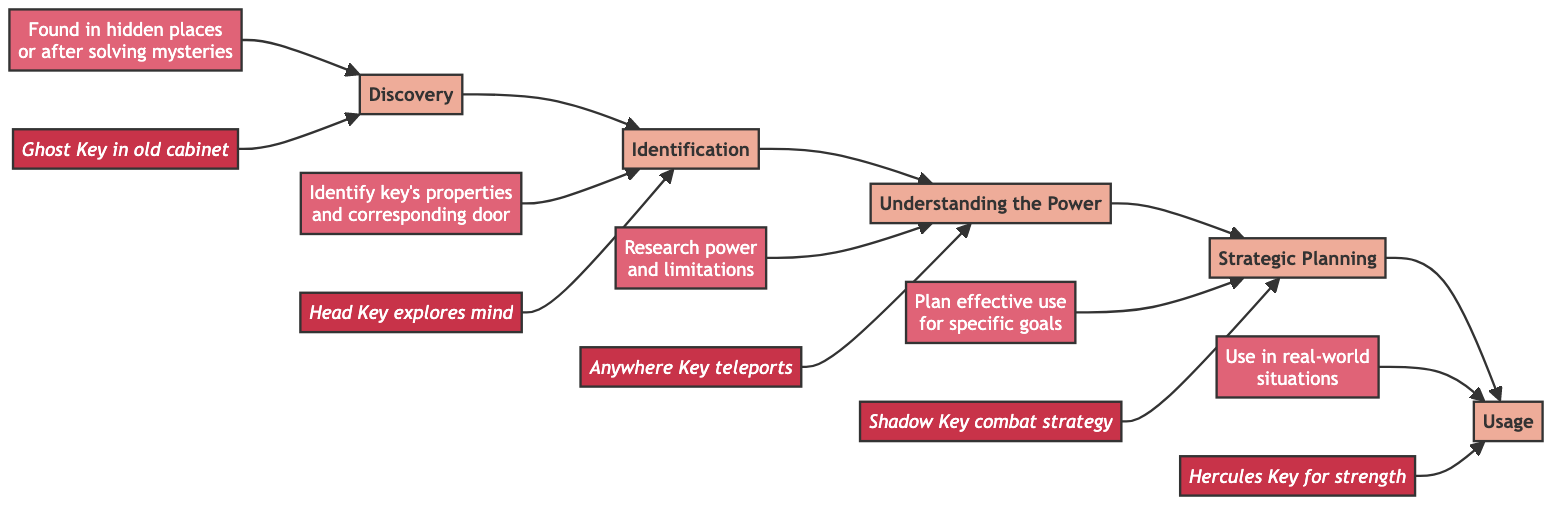What is the first stage in the journey of a key? The first stage is the beginning of the flowchart, labeled "Discovery" which is simply observable from the leftmost position in the diagram.
Answer: Discovery How many stages are there in the key's journey? Counting the stages listed sequentially in the flowchart, we can see there are five stages: Discovery, Identification, Understanding the Power, Strategic Planning, and Usage.
Answer: 5 What follows the "Identification" stage? By looking at the flowchart, we see that the node immediately after "Identification" is the "Understanding the Power" stage, indicating the sequences in which the stages occur.
Answer: Understanding the Power Which key is associated with the "Strategic Planning" stage? In the diagram, the key linked with Strategic Planning is the "Shadow Key," which is explicitly assigned as an example for this stage.
Answer: Shadow Key What is the relationship between "Understanding the Power" and "Usage"? The flowchart connects these two stages directly, with a directional arrow indicating that "Usage" follows "Understanding the Power," establishing a sequential relationship.
Answer: Sequential Identify an example provided in the "Discovery" stage. The diagram includes "Ghost Key in old cabinet" as a specific example associated with the Discovery stage, which can be clearly seen mentioned in the respective section.
Answer: Ghost Key in old cabinet Which stage involves researching the power and limitations of the key? The description associated with "Understanding the Power" specifies activities involving research regarding the key's abilities, placing it as the correct stage for this activity.
Answer: Understanding the Power What is the main objective during the "Strategic Planning" stage? Looking at the associated description for the Strategic Planning stage, the main objective is to "plan effective use for specific goals," highlighting its purpose in the process.
Answer: Plan effective use for specific goals What example is linked with the "Usage" stage? The example directly aligned with "Usage" on the flowchart is the "Hercules Key for strength," clearly annotated in the respective section of the diagram.
Answer: Hercules Key for strength 